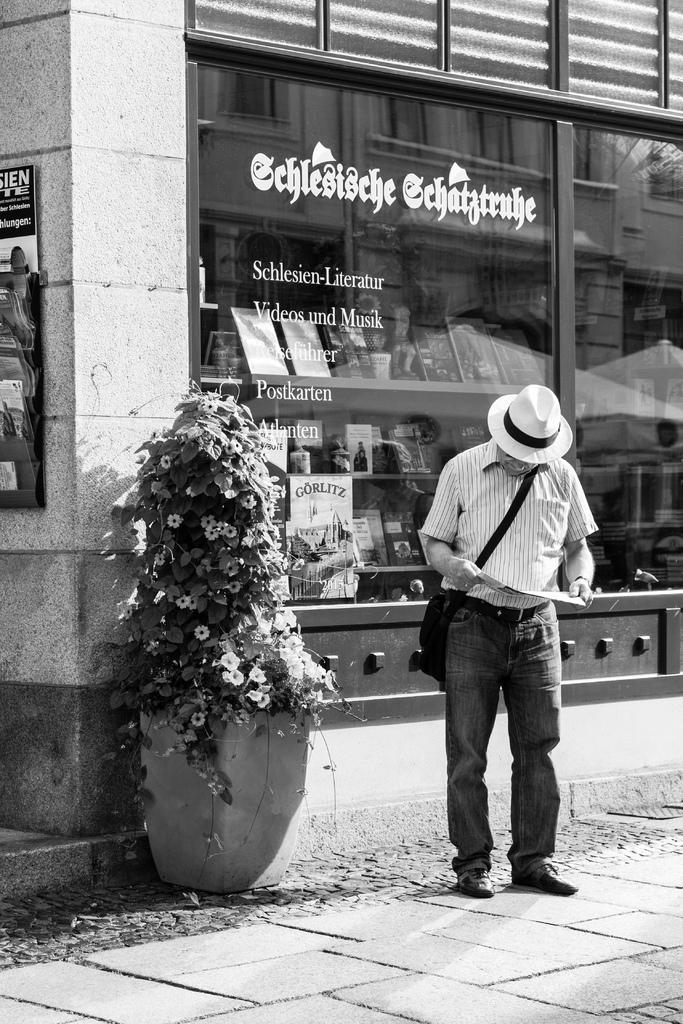What is the person in the image doing? The person is standing and reading something. Can you describe any other objects in the image? Yes, there is a plant in a pot in the image. What is visible in the background of the image? There is a store visible behind the person. How many leaves can be seen on the person's breath in the image? There are no leaves visible on the person's breath in the image, as leaves are not associated with breath. 